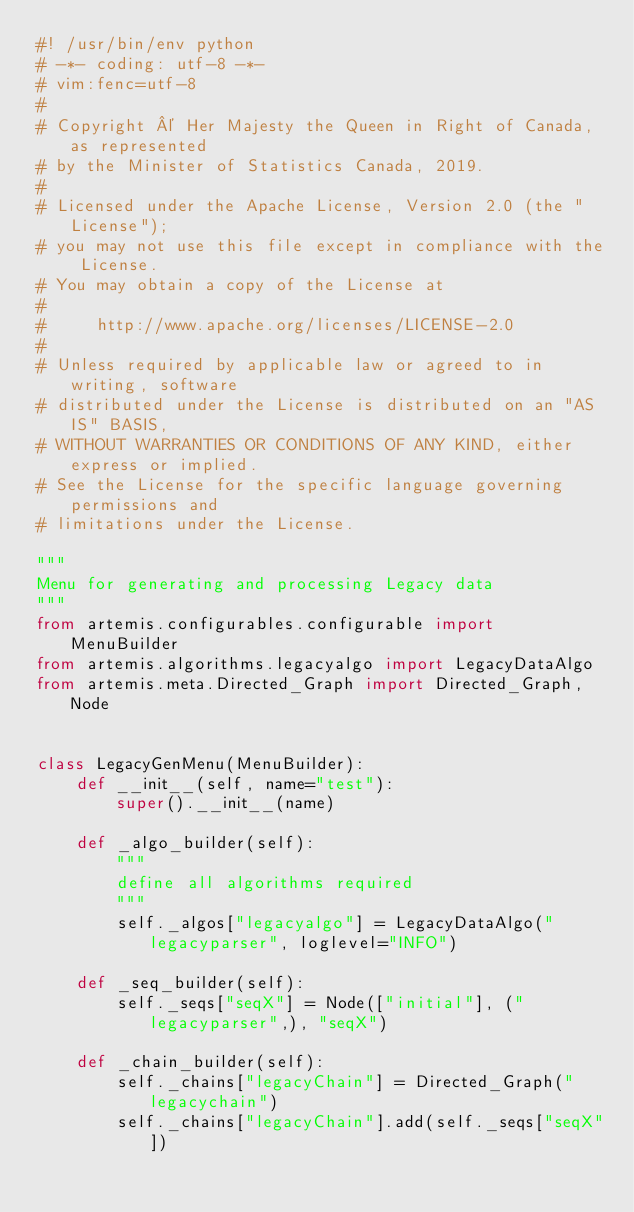Convert code to text. <code><loc_0><loc_0><loc_500><loc_500><_Python_>#! /usr/bin/env python
# -*- coding: utf-8 -*-
# vim:fenc=utf-8
#
# Copyright © Her Majesty the Queen in Right of Canada, as represented
# by the Minister of Statistics Canada, 2019.
#
# Licensed under the Apache License, Version 2.0 (the "License");
# you may not use this file except in compliance with the License.
# You may obtain a copy of the License at
#
#     http://www.apache.org/licenses/LICENSE-2.0
#
# Unless required by applicable law or agreed to in writing, software
# distributed under the License is distributed on an "AS IS" BASIS,
# WITHOUT WARRANTIES OR CONDITIONS OF ANY KIND, either express or implied.
# See the License for the specific language governing permissions and
# limitations under the License.

"""
Menu for generating and processing Legacy data
"""
from artemis.configurables.configurable import MenuBuilder
from artemis.algorithms.legacyalgo import LegacyDataAlgo
from artemis.meta.Directed_Graph import Directed_Graph, Node


class LegacyGenMenu(MenuBuilder):
    def __init__(self, name="test"):
        super().__init__(name)

    def _algo_builder(self):
        """
        define all algorithms required
        """
        self._algos["legacyalgo"] = LegacyDataAlgo("legacyparser", loglevel="INFO")

    def _seq_builder(self):
        self._seqs["seqX"] = Node(["initial"], ("legacyparser",), "seqX")

    def _chain_builder(self):
        self._chains["legacyChain"] = Directed_Graph("legacychain")
        self._chains["legacyChain"].add(self._seqs["seqX"])
</code> 